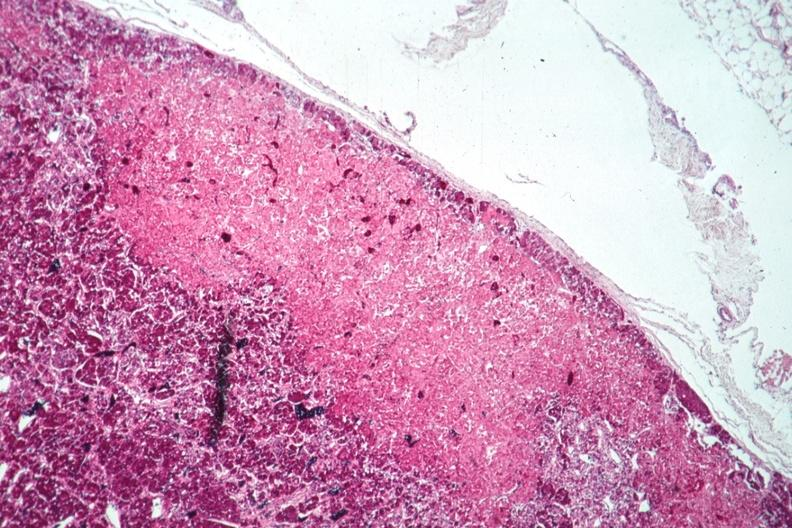s pituitary present?
Answer the question using a single word or phrase. Yes 